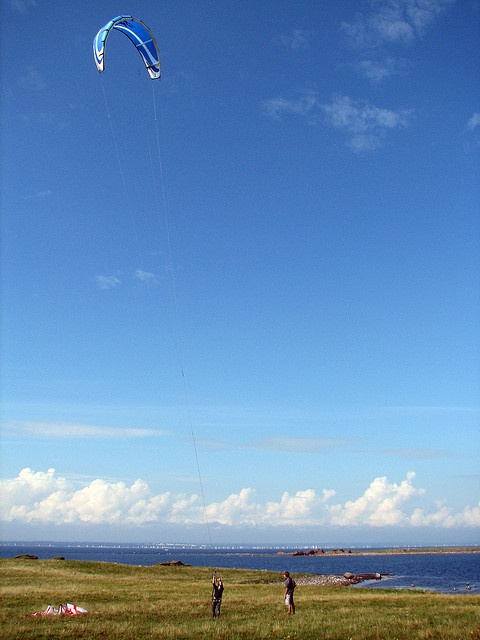Describe the objects in this image and their specific colors. I can see kite in blue, darkblue, and white tones, people in blue, black, maroon, olive, and gray tones, people in blue, black, maroon, olive, and gray tones, and kite in blue, lightgray, brown, red, and lightpink tones in this image. 